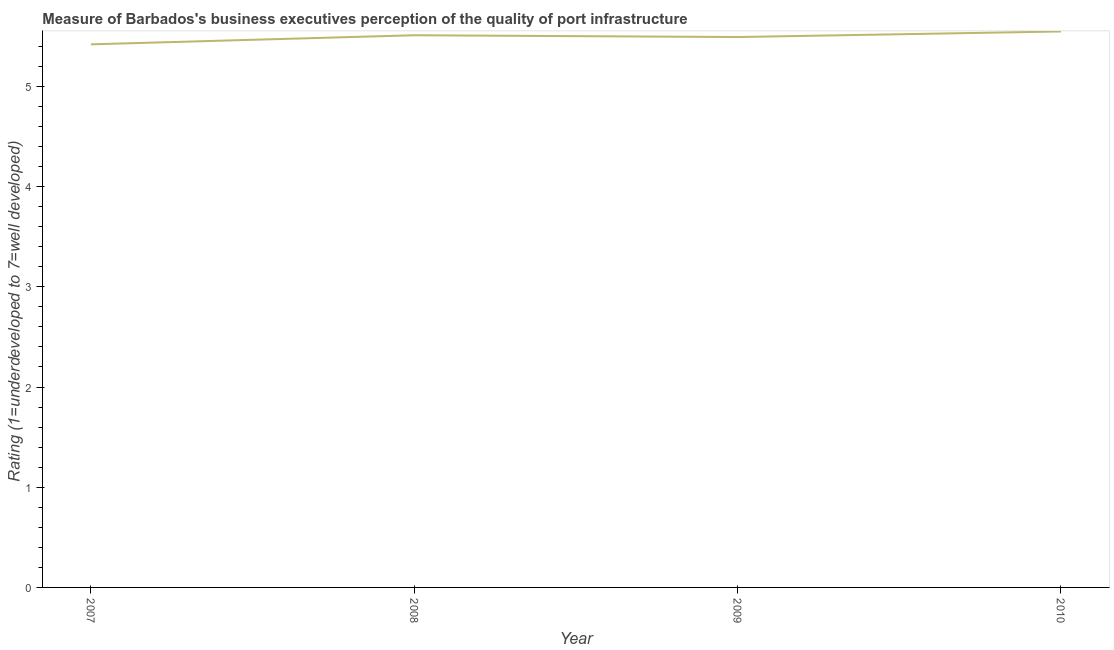What is the rating measuring quality of port infrastructure in 2010?
Keep it short and to the point. 5.55. Across all years, what is the maximum rating measuring quality of port infrastructure?
Offer a very short reply. 5.55. Across all years, what is the minimum rating measuring quality of port infrastructure?
Your answer should be very brief. 5.42. What is the sum of the rating measuring quality of port infrastructure?
Offer a terse response. 21.97. What is the difference between the rating measuring quality of port infrastructure in 2009 and 2010?
Make the answer very short. -0.06. What is the average rating measuring quality of port infrastructure per year?
Offer a very short reply. 5.49. What is the median rating measuring quality of port infrastructure?
Keep it short and to the point. 5.5. What is the ratio of the rating measuring quality of port infrastructure in 2009 to that in 2010?
Provide a short and direct response. 0.99. Is the rating measuring quality of port infrastructure in 2007 less than that in 2008?
Ensure brevity in your answer.  Yes. Is the difference between the rating measuring quality of port infrastructure in 2008 and 2009 greater than the difference between any two years?
Give a very brief answer. No. What is the difference between the highest and the second highest rating measuring quality of port infrastructure?
Ensure brevity in your answer.  0.04. Is the sum of the rating measuring quality of port infrastructure in 2008 and 2010 greater than the maximum rating measuring quality of port infrastructure across all years?
Make the answer very short. Yes. What is the difference between the highest and the lowest rating measuring quality of port infrastructure?
Provide a succinct answer. 0.13. How many years are there in the graph?
Keep it short and to the point. 4. Are the values on the major ticks of Y-axis written in scientific E-notation?
Provide a short and direct response. No. Does the graph contain grids?
Make the answer very short. No. What is the title of the graph?
Make the answer very short. Measure of Barbados's business executives perception of the quality of port infrastructure. What is the label or title of the X-axis?
Your response must be concise. Year. What is the label or title of the Y-axis?
Offer a terse response. Rating (1=underdeveloped to 7=well developed) . What is the Rating (1=underdeveloped to 7=well developed)  of 2007?
Your answer should be very brief. 5.42. What is the Rating (1=underdeveloped to 7=well developed)  in 2008?
Offer a very short reply. 5.51. What is the Rating (1=underdeveloped to 7=well developed)  in 2009?
Give a very brief answer. 5.49. What is the Rating (1=underdeveloped to 7=well developed)  of 2010?
Provide a short and direct response. 5.55. What is the difference between the Rating (1=underdeveloped to 7=well developed)  in 2007 and 2008?
Your answer should be compact. -0.09. What is the difference between the Rating (1=underdeveloped to 7=well developed)  in 2007 and 2009?
Provide a short and direct response. -0.07. What is the difference between the Rating (1=underdeveloped to 7=well developed)  in 2007 and 2010?
Give a very brief answer. -0.13. What is the difference between the Rating (1=underdeveloped to 7=well developed)  in 2008 and 2009?
Offer a terse response. 0.02. What is the difference between the Rating (1=underdeveloped to 7=well developed)  in 2008 and 2010?
Keep it short and to the point. -0.04. What is the difference between the Rating (1=underdeveloped to 7=well developed)  in 2009 and 2010?
Keep it short and to the point. -0.06. What is the ratio of the Rating (1=underdeveloped to 7=well developed)  in 2007 to that in 2008?
Offer a very short reply. 0.98. What is the ratio of the Rating (1=underdeveloped to 7=well developed)  in 2007 to that in 2010?
Make the answer very short. 0.98. What is the ratio of the Rating (1=underdeveloped to 7=well developed)  in 2008 to that in 2010?
Your response must be concise. 0.99. What is the ratio of the Rating (1=underdeveloped to 7=well developed)  in 2009 to that in 2010?
Offer a terse response. 0.99. 